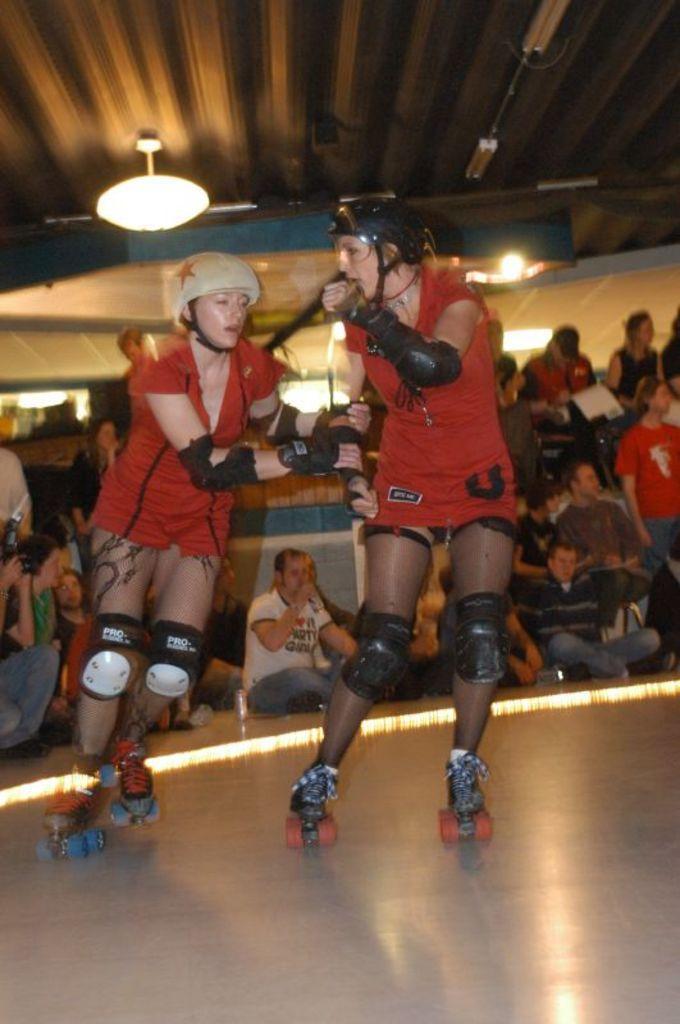Please provide a concise description of this image. In the center of the image we can see two ladies skating on the floor. In the background there are people sitting. At the top there are lights. 